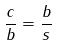<formula> <loc_0><loc_0><loc_500><loc_500>\frac { c } { b } = \frac { b } { s }</formula> 